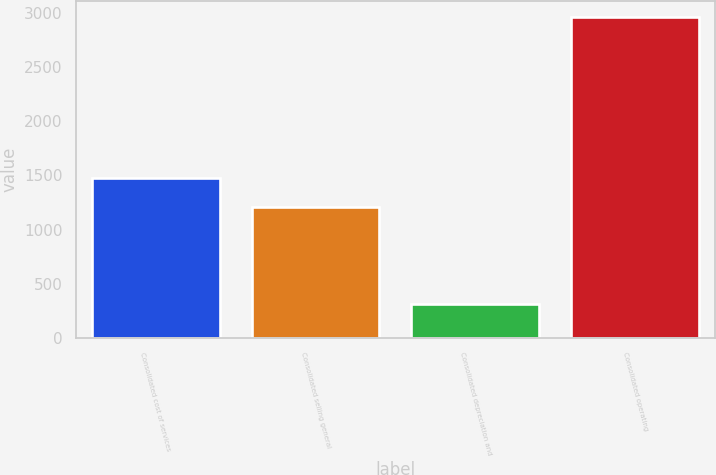<chart> <loc_0><loc_0><loc_500><loc_500><bar_chart><fcel>Consolidated cost of services<fcel>Consolidated selling general<fcel>Consolidated depreciation and<fcel>Consolidated operating<nl><fcel>1478.67<fcel>1213.3<fcel>310.4<fcel>2964.1<nl></chart> 